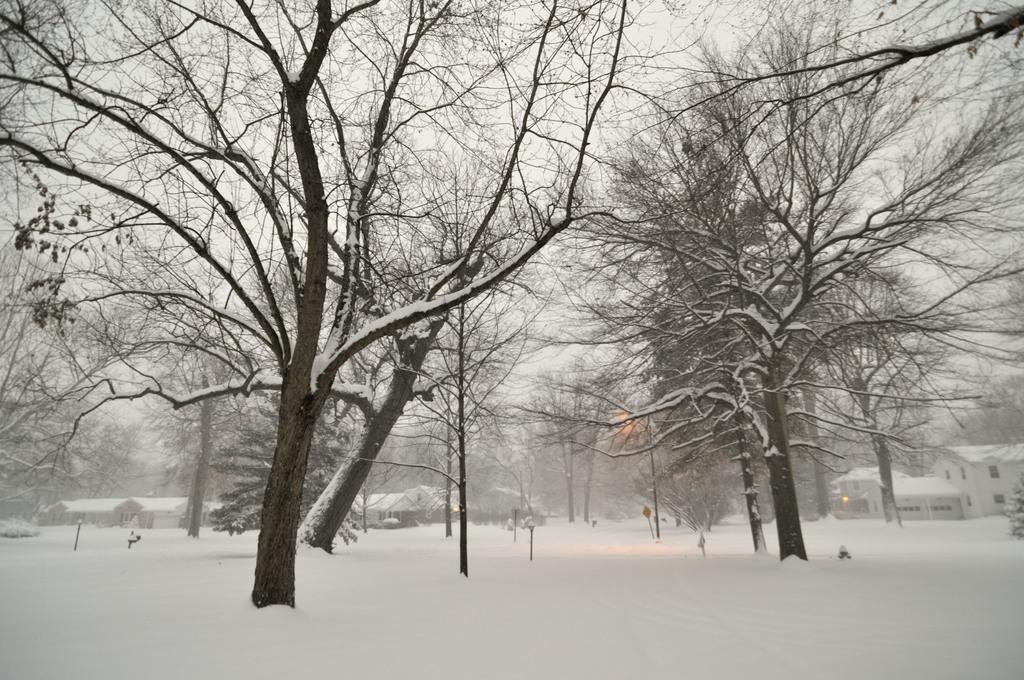What type of weather condition is depicted in the image? There is snow in the image, indicating a winter scene. What type of natural elements can be seen in the image? There are trees in the image. What man-made structures are present in the image? There are poles and a board in the image. What can be seen in the distance in the image? There are houses in the background of the image, and the sky is visible in the background as well. How long does the fog last in the image? There is no fog present in the image; it features snow instead. What type of nail is being used to hang the board in the image? There is no nail visible in the image, as the board is not being hung up. 